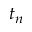<formula> <loc_0><loc_0><loc_500><loc_500>t _ { n }</formula> 